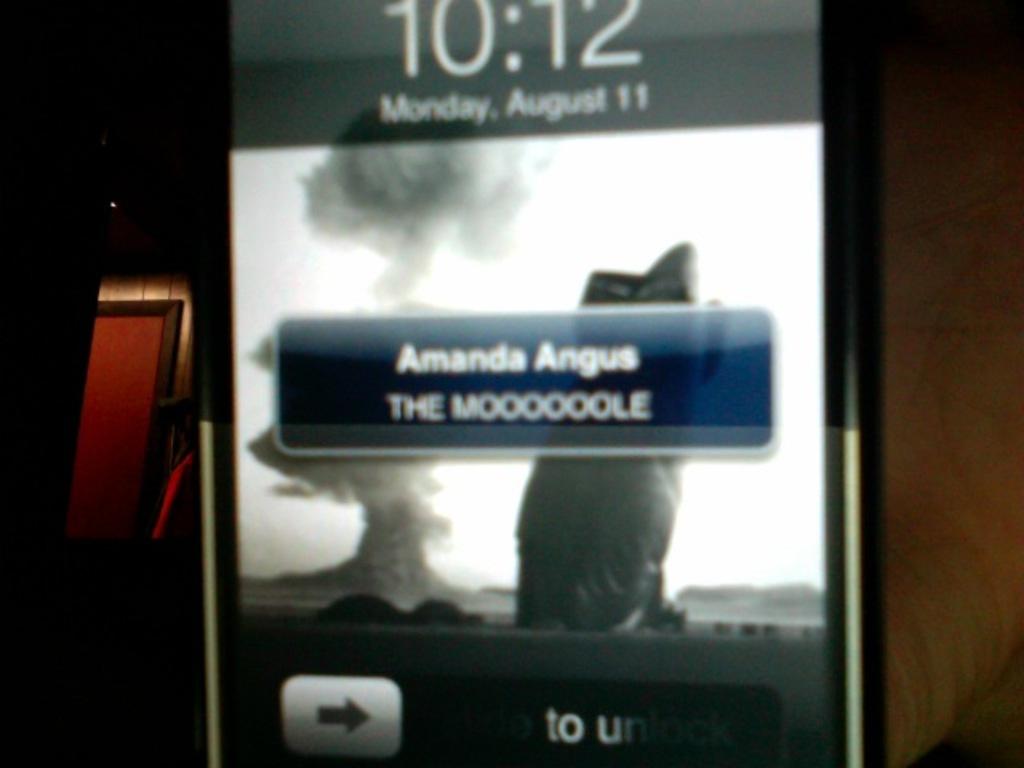What is the name of the person in the message?
Make the answer very short. Amanda angus. What time is it?
Offer a terse response. 10:12. 